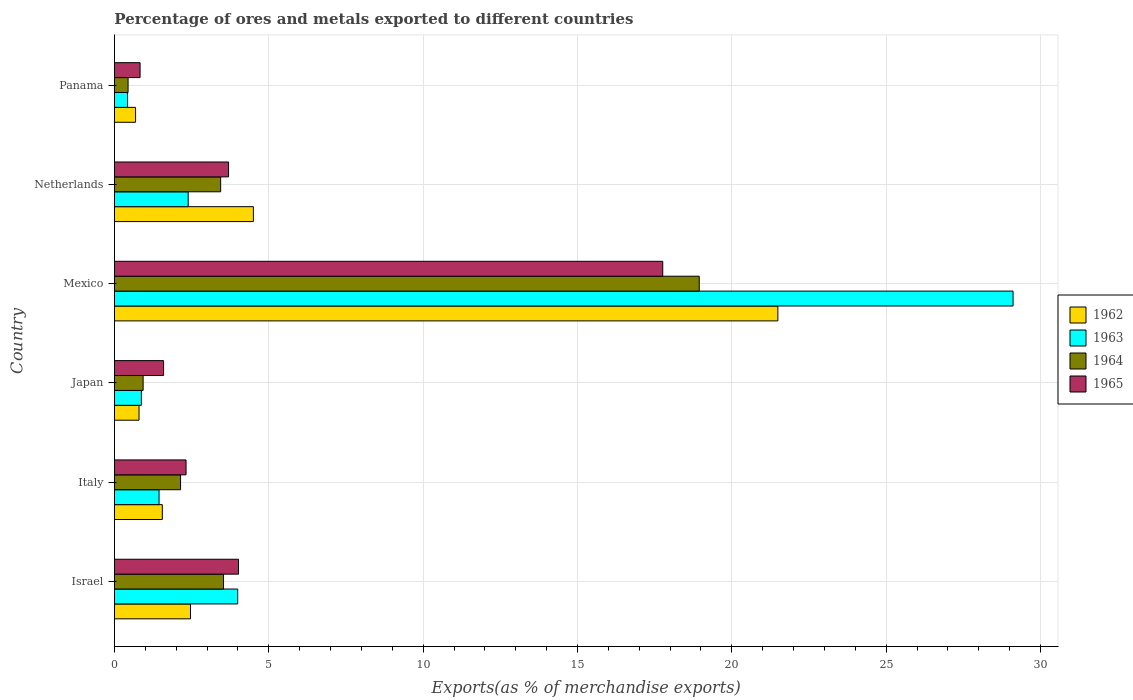How many different coloured bars are there?
Offer a terse response. 4. How many groups of bars are there?
Offer a terse response. 6. Are the number of bars per tick equal to the number of legend labels?
Make the answer very short. Yes. Are the number of bars on each tick of the Y-axis equal?
Your response must be concise. Yes. What is the percentage of exports to different countries in 1964 in Netherlands?
Make the answer very short. 3.44. Across all countries, what is the maximum percentage of exports to different countries in 1962?
Keep it short and to the point. 21.49. Across all countries, what is the minimum percentage of exports to different countries in 1963?
Your answer should be very brief. 0.43. In which country was the percentage of exports to different countries in 1964 minimum?
Ensure brevity in your answer.  Panama. What is the total percentage of exports to different countries in 1964 in the graph?
Keep it short and to the point. 29.43. What is the difference between the percentage of exports to different countries in 1963 in Mexico and that in Netherlands?
Your answer should be very brief. 26.72. What is the difference between the percentage of exports to different countries in 1962 in Mexico and the percentage of exports to different countries in 1964 in Netherlands?
Offer a very short reply. 18.05. What is the average percentage of exports to different countries in 1964 per country?
Your response must be concise. 4.91. What is the difference between the percentage of exports to different countries in 1965 and percentage of exports to different countries in 1964 in Panama?
Provide a succinct answer. 0.39. What is the ratio of the percentage of exports to different countries in 1963 in Israel to that in Italy?
Your answer should be compact. 2.76. Is the difference between the percentage of exports to different countries in 1965 in Italy and Netherlands greater than the difference between the percentage of exports to different countries in 1964 in Italy and Netherlands?
Your response must be concise. No. What is the difference between the highest and the second highest percentage of exports to different countries in 1963?
Make the answer very short. 25.12. What is the difference between the highest and the lowest percentage of exports to different countries in 1964?
Provide a succinct answer. 18.5. In how many countries, is the percentage of exports to different countries in 1962 greater than the average percentage of exports to different countries in 1962 taken over all countries?
Give a very brief answer. 1. What does the 3rd bar from the bottom in Israel represents?
Provide a succinct answer. 1964. Is it the case that in every country, the sum of the percentage of exports to different countries in 1965 and percentage of exports to different countries in 1962 is greater than the percentage of exports to different countries in 1964?
Keep it short and to the point. Yes. How many bars are there?
Your answer should be very brief. 24. Are the values on the major ticks of X-axis written in scientific E-notation?
Offer a terse response. No. Does the graph contain grids?
Your answer should be compact. Yes. Where does the legend appear in the graph?
Offer a very short reply. Center right. How many legend labels are there?
Ensure brevity in your answer.  4. How are the legend labels stacked?
Offer a terse response. Vertical. What is the title of the graph?
Your answer should be very brief. Percentage of ores and metals exported to different countries. Does "2012" appear as one of the legend labels in the graph?
Your answer should be very brief. No. What is the label or title of the X-axis?
Offer a terse response. Exports(as % of merchandise exports). What is the Exports(as % of merchandise exports) of 1962 in Israel?
Provide a short and direct response. 2.46. What is the Exports(as % of merchandise exports) in 1963 in Israel?
Your answer should be compact. 3.99. What is the Exports(as % of merchandise exports) of 1964 in Israel?
Ensure brevity in your answer.  3.53. What is the Exports(as % of merchandise exports) in 1965 in Israel?
Provide a succinct answer. 4.02. What is the Exports(as % of merchandise exports) in 1962 in Italy?
Ensure brevity in your answer.  1.55. What is the Exports(as % of merchandise exports) of 1963 in Italy?
Your answer should be compact. 1.45. What is the Exports(as % of merchandise exports) of 1964 in Italy?
Give a very brief answer. 2.14. What is the Exports(as % of merchandise exports) of 1965 in Italy?
Give a very brief answer. 2.32. What is the Exports(as % of merchandise exports) in 1962 in Japan?
Keep it short and to the point. 0.8. What is the Exports(as % of merchandise exports) of 1963 in Japan?
Provide a short and direct response. 0.87. What is the Exports(as % of merchandise exports) in 1964 in Japan?
Your answer should be very brief. 0.93. What is the Exports(as % of merchandise exports) of 1965 in Japan?
Provide a succinct answer. 1.59. What is the Exports(as % of merchandise exports) in 1962 in Mexico?
Ensure brevity in your answer.  21.49. What is the Exports(as % of merchandise exports) in 1963 in Mexico?
Make the answer very short. 29.11. What is the Exports(as % of merchandise exports) of 1964 in Mexico?
Your answer should be very brief. 18.94. What is the Exports(as % of merchandise exports) in 1965 in Mexico?
Keep it short and to the point. 17.76. What is the Exports(as % of merchandise exports) in 1962 in Netherlands?
Give a very brief answer. 4.5. What is the Exports(as % of merchandise exports) in 1963 in Netherlands?
Provide a short and direct response. 2.39. What is the Exports(as % of merchandise exports) of 1964 in Netherlands?
Your answer should be compact. 3.44. What is the Exports(as % of merchandise exports) in 1965 in Netherlands?
Offer a very short reply. 3.7. What is the Exports(as % of merchandise exports) in 1962 in Panama?
Give a very brief answer. 0.69. What is the Exports(as % of merchandise exports) in 1963 in Panama?
Offer a terse response. 0.43. What is the Exports(as % of merchandise exports) in 1964 in Panama?
Keep it short and to the point. 0.44. What is the Exports(as % of merchandise exports) of 1965 in Panama?
Your answer should be compact. 0.83. Across all countries, what is the maximum Exports(as % of merchandise exports) of 1962?
Ensure brevity in your answer.  21.49. Across all countries, what is the maximum Exports(as % of merchandise exports) in 1963?
Ensure brevity in your answer.  29.11. Across all countries, what is the maximum Exports(as % of merchandise exports) in 1964?
Provide a succinct answer. 18.94. Across all countries, what is the maximum Exports(as % of merchandise exports) of 1965?
Provide a succinct answer. 17.76. Across all countries, what is the minimum Exports(as % of merchandise exports) of 1962?
Ensure brevity in your answer.  0.69. Across all countries, what is the minimum Exports(as % of merchandise exports) of 1963?
Make the answer very short. 0.43. Across all countries, what is the minimum Exports(as % of merchandise exports) of 1964?
Provide a short and direct response. 0.44. Across all countries, what is the minimum Exports(as % of merchandise exports) in 1965?
Provide a succinct answer. 0.83. What is the total Exports(as % of merchandise exports) of 1962 in the graph?
Provide a succinct answer. 31.49. What is the total Exports(as % of merchandise exports) in 1963 in the graph?
Provide a succinct answer. 38.24. What is the total Exports(as % of merchandise exports) in 1964 in the graph?
Your response must be concise. 29.43. What is the total Exports(as % of merchandise exports) of 1965 in the graph?
Provide a succinct answer. 30.22. What is the difference between the Exports(as % of merchandise exports) in 1963 in Israel and that in Italy?
Your answer should be compact. 2.55. What is the difference between the Exports(as % of merchandise exports) in 1964 in Israel and that in Italy?
Offer a very short reply. 1.39. What is the difference between the Exports(as % of merchandise exports) in 1965 in Israel and that in Italy?
Provide a short and direct response. 1.7. What is the difference between the Exports(as % of merchandise exports) in 1962 in Israel and that in Japan?
Offer a terse response. 1.67. What is the difference between the Exports(as % of merchandise exports) of 1963 in Israel and that in Japan?
Ensure brevity in your answer.  3.12. What is the difference between the Exports(as % of merchandise exports) of 1964 in Israel and that in Japan?
Offer a terse response. 2.6. What is the difference between the Exports(as % of merchandise exports) in 1965 in Israel and that in Japan?
Your response must be concise. 2.43. What is the difference between the Exports(as % of merchandise exports) in 1962 in Israel and that in Mexico?
Provide a succinct answer. -19.03. What is the difference between the Exports(as % of merchandise exports) of 1963 in Israel and that in Mexico?
Make the answer very short. -25.12. What is the difference between the Exports(as % of merchandise exports) in 1964 in Israel and that in Mexico?
Your answer should be very brief. -15.41. What is the difference between the Exports(as % of merchandise exports) of 1965 in Israel and that in Mexico?
Provide a short and direct response. -13.74. What is the difference between the Exports(as % of merchandise exports) in 1962 in Israel and that in Netherlands?
Ensure brevity in your answer.  -2.04. What is the difference between the Exports(as % of merchandise exports) in 1963 in Israel and that in Netherlands?
Keep it short and to the point. 1.6. What is the difference between the Exports(as % of merchandise exports) of 1964 in Israel and that in Netherlands?
Your answer should be very brief. 0.09. What is the difference between the Exports(as % of merchandise exports) of 1965 in Israel and that in Netherlands?
Provide a short and direct response. 0.32. What is the difference between the Exports(as % of merchandise exports) in 1962 in Israel and that in Panama?
Provide a succinct answer. 1.78. What is the difference between the Exports(as % of merchandise exports) in 1963 in Israel and that in Panama?
Make the answer very short. 3.57. What is the difference between the Exports(as % of merchandise exports) of 1964 in Israel and that in Panama?
Offer a very short reply. 3.09. What is the difference between the Exports(as % of merchandise exports) of 1965 in Israel and that in Panama?
Provide a short and direct response. 3.19. What is the difference between the Exports(as % of merchandise exports) in 1962 in Italy and that in Japan?
Your response must be concise. 0.75. What is the difference between the Exports(as % of merchandise exports) of 1963 in Italy and that in Japan?
Your response must be concise. 0.57. What is the difference between the Exports(as % of merchandise exports) of 1964 in Italy and that in Japan?
Your answer should be compact. 1.21. What is the difference between the Exports(as % of merchandise exports) of 1965 in Italy and that in Japan?
Provide a short and direct response. 0.73. What is the difference between the Exports(as % of merchandise exports) of 1962 in Italy and that in Mexico?
Offer a very short reply. -19.94. What is the difference between the Exports(as % of merchandise exports) in 1963 in Italy and that in Mexico?
Ensure brevity in your answer.  -27.66. What is the difference between the Exports(as % of merchandise exports) in 1964 in Italy and that in Mexico?
Provide a short and direct response. -16.8. What is the difference between the Exports(as % of merchandise exports) in 1965 in Italy and that in Mexico?
Make the answer very short. -15.44. What is the difference between the Exports(as % of merchandise exports) in 1962 in Italy and that in Netherlands?
Ensure brevity in your answer.  -2.95. What is the difference between the Exports(as % of merchandise exports) of 1963 in Italy and that in Netherlands?
Ensure brevity in your answer.  -0.94. What is the difference between the Exports(as % of merchandise exports) in 1964 in Italy and that in Netherlands?
Ensure brevity in your answer.  -1.3. What is the difference between the Exports(as % of merchandise exports) in 1965 in Italy and that in Netherlands?
Provide a succinct answer. -1.38. What is the difference between the Exports(as % of merchandise exports) of 1962 in Italy and that in Panama?
Give a very brief answer. 0.87. What is the difference between the Exports(as % of merchandise exports) of 1963 in Italy and that in Panama?
Your answer should be very brief. 1.02. What is the difference between the Exports(as % of merchandise exports) of 1964 in Italy and that in Panama?
Your answer should be very brief. 1.7. What is the difference between the Exports(as % of merchandise exports) of 1965 in Italy and that in Panama?
Offer a very short reply. 1.49. What is the difference between the Exports(as % of merchandise exports) in 1962 in Japan and that in Mexico?
Give a very brief answer. -20.69. What is the difference between the Exports(as % of merchandise exports) of 1963 in Japan and that in Mexico?
Your response must be concise. -28.24. What is the difference between the Exports(as % of merchandise exports) in 1964 in Japan and that in Mexico?
Ensure brevity in your answer.  -18.01. What is the difference between the Exports(as % of merchandise exports) of 1965 in Japan and that in Mexico?
Provide a short and direct response. -16.17. What is the difference between the Exports(as % of merchandise exports) in 1962 in Japan and that in Netherlands?
Offer a terse response. -3.7. What is the difference between the Exports(as % of merchandise exports) of 1963 in Japan and that in Netherlands?
Keep it short and to the point. -1.52. What is the difference between the Exports(as % of merchandise exports) of 1964 in Japan and that in Netherlands?
Your answer should be very brief. -2.51. What is the difference between the Exports(as % of merchandise exports) in 1965 in Japan and that in Netherlands?
Your answer should be compact. -2.11. What is the difference between the Exports(as % of merchandise exports) of 1962 in Japan and that in Panama?
Keep it short and to the point. 0.11. What is the difference between the Exports(as % of merchandise exports) of 1963 in Japan and that in Panama?
Your response must be concise. 0.45. What is the difference between the Exports(as % of merchandise exports) of 1964 in Japan and that in Panama?
Your answer should be compact. 0.49. What is the difference between the Exports(as % of merchandise exports) in 1965 in Japan and that in Panama?
Make the answer very short. 0.76. What is the difference between the Exports(as % of merchandise exports) of 1962 in Mexico and that in Netherlands?
Provide a succinct answer. 16.99. What is the difference between the Exports(as % of merchandise exports) of 1963 in Mexico and that in Netherlands?
Your answer should be compact. 26.72. What is the difference between the Exports(as % of merchandise exports) in 1964 in Mexico and that in Netherlands?
Provide a succinct answer. 15.5. What is the difference between the Exports(as % of merchandise exports) of 1965 in Mexico and that in Netherlands?
Offer a very short reply. 14.06. What is the difference between the Exports(as % of merchandise exports) of 1962 in Mexico and that in Panama?
Make the answer very short. 20.81. What is the difference between the Exports(as % of merchandise exports) in 1963 in Mexico and that in Panama?
Your response must be concise. 28.68. What is the difference between the Exports(as % of merchandise exports) in 1964 in Mexico and that in Panama?
Give a very brief answer. 18.5. What is the difference between the Exports(as % of merchandise exports) in 1965 in Mexico and that in Panama?
Make the answer very short. 16.93. What is the difference between the Exports(as % of merchandise exports) in 1962 in Netherlands and that in Panama?
Keep it short and to the point. 3.82. What is the difference between the Exports(as % of merchandise exports) of 1963 in Netherlands and that in Panama?
Keep it short and to the point. 1.96. What is the difference between the Exports(as % of merchandise exports) of 1964 in Netherlands and that in Panama?
Your answer should be compact. 3. What is the difference between the Exports(as % of merchandise exports) in 1965 in Netherlands and that in Panama?
Provide a short and direct response. 2.87. What is the difference between the Exports(as % of merchandise exports) of 1962 in Israel and the Exports(as % of merchandise exports) of 1963 in Italy?
Your response must be concise. 1.02. What is the difference between the Exports(as % of merchandise exports) of 1962 in Israel and the Exports(as % of merchandise exports) of 1964 in Italy?
Keep it short and to the point. 0.32. What is the difference between the Exports(as % of merchandise exports) of 1962 in Israel and the Exports(as % of merchandise exports) of 1965 in Italy?
Your response must be concise. 0.14. What is the difference between the Exports(as % of merchandise exports) of 1963 in Israel and the Exports(as % of merchandise exports) of 1964 in Italy?
Give a very brief answer. 1.85. What is the difference between the Exports(as % of merchandise exports) in 1963 in Israel and the Exports(as % of merchandise exports) in 1965 in Italy?
Make the answer very short. 1.67. What is the difference between the Exports(as % of merchandise exports) of 1964 in Israel and the Exports(as % of merchandise exports) of 1965 in Italy?
Your answer should be compact. 1.21. What is the difference between the Exports(as % of merchandise exports) in 1962 in Israel and the Exports(as % of merchandise exports) in 1963 in Japan?
Your answer should be compact. 1.59. What is the difference between the Exports(as % of merchandise exports) in 1962 in Israel and the Exports(as % of merchandise exports) in 1964 in Japan?
Your response must be concise. 1.53. What is the difference between the Exports(as % of merchandise exports) in 1962 in Israel and the Exports(as % of merchandise exports) in 1965 in Japan?
Offer a terse response. 0.87. What is the difference between the Exports(as % of merchandise exports) of 1963 in Israel and the Exports(as % of merchandise exports) of 1964 in Japan?
Ensure brevity in your answer.  3.06. What is the difference between the Exports(as % of merchandise exports) of 1963 in Israel and the Exports(as % of merchandise exports) of 1965 in Japan?
Make the answer very short. 2.4. What is the difference between the Exports(as % of merchandise exports) of 1964 in Israel and the Exports(as % of merchandise exports) of 1965 in Japan?
Ensure brevity in your answer.  1.94. What is the difference between the Exports(as % of merchandise exports) of 1962 in Israel and the Exports(as % of merchandise exports) of 1963 in Mexico?
Ensure brevity in your answer.  -26.64. What is the difference between the Exports(as % of merchandise exports) of 1962 in Israel and the Exports(as % of merchandise exports) of 1964 in Mexico?
Keep it short and to the point. -16.48. What is the difference between the Exports(as % of merchandise exports) of 1962 in Israel and the Exports(as % of merchandise exports) of 1965 in Mexico?
Offer a very short reply. -15.3. What is the difference between the Exports(as % of merchandise exports) of 1963 in Israel and the Exports(as % of merchandise exports) of 1964 in Mexico?
Make the answer very short. -14.95. What is the difference between the Exports(as % of merchandise exports) of 1963 in Israel and the Exports(as % of merchandise exports) of 1965 in Mexico?
Give a very brief answer. -13.77. What is the difference between the Exports(as % of merchandise exports) of 1964 in Israel and the Exports(as % of merchandise exports) of 1965 in Mexico?
Make the answer very short. -14.23. What is the difference between the Exports(as % of merchandise exports) of 1962 in Israel and the Exports(as % of merchandise exports) of 1963 in Netherlands?
Give a very brief answer. 0.07. What is the difference between the Exports(as % of merchandise exports) of 1962 in Israel and the Exports(as % of merchandise exports) of 1964 in Netherlands?
Offer a terse response. -0.98. What is the difference between the Exports(as % of merchandise exports) in 1962 in Israel and the Exports(as % of merchandise exports) in 1965 in Netherlands?
Your answer should be compact. -1.23. What is the difference between the Exports(as % of merchandise exports) of 1963 in Israel and the Exports(as % of merchandise exports) of 1964 in Netherlands?
Provide a succinct answer. 0.55. What is the difference between the Exports(as % of merchandise exports) of 1963 in Israel and the Exports(as % of merchandise exports) of 1965 in Netherlands?
Offer a terse response. 0.3. What is the difference between the Exports(as % of merchandise exports) of 1964 in Israel and the Exports(as % of merchandise exports) of 1965 in Netherlands?
Provide a short and direct response. -0.16. What is the difference between the Exports(as % of merchandise exports) in 1962 in Israel and the Exports(as % of merchandise exports) in 1963 in Panama?
Make the answer very short. 2.04. What is the difference between the Exports(as % of merchandise exports) of 1962 in Israel and the Exports(as % of merchandise exports) of 1964 in Panama?
Your answer should be very brief. 2.02. What is the difference between the Exports(as % of merchandise exports) of 1962 in Israel and the Exports(as % of merchandise exports) of 1965 in Panama?
Offer a terse response. 1.63. What is the difference between the Exports(as % of merchandise exports) of 1963 in Israel and the Exports(as % of merchandise exports) of 1964 in Panama?
Provide a short and direct response. 3.55. What is the difference between the Exports(as % of merchandise exports) of 1963 in Israel and the Exports(as % of merchandise exports) of 1965 in Panama?
Your answer should be very brief. 3.16. What is the difference between the Exports(as % of merchandise exports) of 1964 in Israel and the Exports(as % of merchandise exports) of 1965 in Panama?
Your response must be concise. 2.7. What is the difference between the Exports(as % of merchandise exports) in 1962 in Italy and the Exports(as % of merchandise exports) in 1963 in Japan?
Make the answer very short. 0.68. What is the difference between the Exports(as % of merchandise exports) in 1962 in Italy and the Exports(as % of merchandise exports) in 1964 in Japan?
Keep it short and to the point. 0.62. What is the difference between the Exports(as % of merchandise exports) of 1962 in Italy and the Exports(as % of merchandise exports) of 1965 in Japan?
Keep it short and to the point. -0.04. What is the difference between the Exports(as % of merchandise exports) of 1963 in Italy and the Exports(as % of merchandise exports) of 1964 in Japan?
Your response must be concise. 0.52. What is the difference between the Exports(as % of merchandise exports) in 1963 in Italy and the Exports(as % of merchandise exports) in 1965 in Japan?
Make the answer very short. -0.15. What is the difference between the Exports(as % of merchandise exports) of 1964 in Italy and the Exports(as % of merchandise exports) of 1965 in Japan?
Provide a short and direct response. 0.55. What is the difference between the Exports(as % of merchandise exports) in 1962 in Italy and the Exports(as % of merchandise exports) in 1963 in Mexico?
Provide a short and direct response. -27.56. What is the difference between the Exports(as % of merchandise exports) of 1962 in Italy and the Exports(as % of merchandise exports) of 1964 in Mexico?
Provide a succinct answer. -17.39. What is the difference between the Exports(as % of merchandise exports) in 1962 in Italy and the Exports(as % of merchandise exports) in 1965 in Mexico?
Ensure brevity in your answer.  -16.21. What is the difference between the Exports(as % of merchandise exports) of 1963 in Italy and the Exports(as % of merchandise exports) of 1964 in Mexico?
Keep it short and to the point. -17.5. What is the difference between the Exports(as % of merchandise exports) of 1963 in Italy and the Exports(as % of merchandise exports) of 1965 in Mexico?
Offer a terse response. -16.32. What is the difference between the Exports(as % of merchandise exports) in 1964 in Italy and the Exports(as % of merchandise exports) in 1965 in Mexico?
Ensure brevity in your answer.  -15.62. What is the difference between the Exports(as % of merchandise exports) in 1962 in Italy and the Exports(as % of merchandise exports) in 1963 in Netherlands?
Provide a short and direct response. -0.84. What is the difference between the Exports(as % of merchandise exports) in 1962 in Italy and the Exports(as % of merchandise exports) in 1964 in Netherlands?
Offer a very short reply. -1.89. What is the difference between the Exports(as % of merchandise exports) of 1962 in Italy and the Exports(as % of merchandise exports) of 1965 in Netherlands?
Provide a succinct answer. -2.15. What is the difference between the Exports(as % of merchandise exports) in 1963 in Italy and the Exports(as % of merchandise exports) in 1964 in Netherlands?
Offer a terse response. -2. What is the difference between the Exports(as % of merchandise exports) in 1963 in Italy and the Exports(as % of merchandise exports) in 1965 in Netherlands?
Your answer should be very brief. -2.25. What is the difference between the Exports(as % of merchandise exports) in 1964 in Italy and the Exports(as % of merchandise exports) in 1965 in Netherlands?
Provide a short and direct response. -1.56. What is the difference between the Exports(as % of merchandise exports) in 1962 in Italy and the Exports(as % of merchandise exports) in 1963 in Panama?
Make the answer very short. 1.12. What is the difference between the Exports(as % of merchandise exports) in 1962 in Italy and the Exports(as % of merchandise exports) in 1964 in Panama?
Ensure brevity in your answer.  1.11. What is the difference between the Exports(as % of merchandise exports) of 1962 in Italy and the Exports(as % of merchandise exports) of 1965 in Panama?
Make the answer very short. 0.72. What is the difference between the Exports(as % of merchandise exports) in 1963 in Italy and the Exports(as % of merchandise exports) in 1965 in Panama?
Make the answer very short. 0.61. What is the difference between the Exports(as % of merchandise exports) in 1964 in Italy and the Exports(as % of merchandise exports) in 1965 in Panama?
Give a very brief answer. 1.31. What is the difference between the Exports(as % of merchandise exports) of 1962 in Japan and the Exports(as % of merchandise exports) of 1963 in Mexico?
Provide a succinct answer. -28.31. What is the difference between the Exports(as % of merchandise exports) in 1962 in Japan and the Exports(as % of merchandise exports) in 1964 in Mexico?
Your answer should be very brief. -18.15. What is the difference between the Exports(as % of merchandise exports) of 1962 in Japan and the Exports(as % of merchandise exports) of 1965 in Mexico?
Keep it short and to the point. -16.97. What is the difference between the Exports(as % of merchandise exports) in 1963 in Japan and the Exports(as % of merchandise exports) in 1964 in Mexico?
Ensure brevity in your answer.  -18.07. What is the difference between the Exports(as % of merchandise exports) of 1963 in Japan and the Exports(as % of merchandise exports) of 1965 in Mexico?
Provide a succinct answer. -16.89. What is the difference between the Exports(as % of merchandise exports) in 1964 in Japan and the Exports(as % of merchandise exports) in 1965 in Mexico?
Your answer should be compact. -16.83. What is the difference between the Exports(as % of merchandise exports) of 1962 in Japan and the Exports(as % of merchandise exports) of 1963 in Netherlands?
Your response must be concise. -1.59. What is the difference between the Exports(as % of merchandise exports) in 1962 in Japan and the Exports(as % of merchandise exports) in 1964 in Netherlands?
Keep it short and to the point. -2.64. What is the difference between the Exports(as % of merchandise exports) of 1962 in Japan and the Exports(as % of merchandise exports) of 1965 in Netherlands?
Offer a very short reply. -2.9. What is the difference between the Exports(as % of merchandise exports) in 1963 in Japan and the Exports(as % of merchandise exports) in 1964 in Netherlands?
Give a very brief answer. -2.57. What is the difference between the Exports(as % of merchandise exports) in 1963 in Japan and the Exports(as % of merchandise exports) in 1965 in Netherlands?
Give a very brief answer. -2.82. What is the difference between the Exports(as % of merchandise exports) in 1964 in Japan and the Exports(as % of merchandise exports) in 1965 in Netherlands?
Keep it short and to the point. -2.77. What is the difference between the Exports(as % of merchandise exports) of 1962 in Japan and the Exports(as % of merchandise exports) of 1963 in Panama?
Keep it short and to the point. 0.37. What is the difference between the Exports(as % of merchandise exports) in 1962 in Japan and the Exports(as % of merchandise exports) in 1964 in Panama?
Offer a terse response. 0.35. What is the difference between the Exports(as % of merchandise exports) in 1962 in Japan and the Exports(as % of merchandise exports) in 1965 in Panama?
Offer a terse response. -0.03. What is the difference between the Exports(as % of merchandise exports) in 1963 in Japan and the Exports(as % of merchandise exports) in 1964 in Panama?
Make the answer very short. 0.43. What is the difference between the Exports(as % of merchandise exports) in 1963 in Japan and the Exports(as % of merchandise exports) in 1965 in Panama?
Provide a succinct answer. 0.04. What is the difference between the Exports(as % of merchandise exports) of 1964 in Japan and the Exports(as % of merchandise exports) of 1965 in Panama?
Offer a very short reply. 0.1. What is the difference between the Exports(as % of merchandise exports) in 1962 in Mexico and the Exports(as % of merchandise exports) in 1963 in Netherlands?
Ensure brevity in your answer.  19.1. What is the difference between the Exports(as % of merchandise exports) in 1962 in Mexico and the Exports(as % of merchandise exports) in 1964 in Netherlands?
Offer a very short reply. 18.05. What is the difference between the Exports(as % of merchandise exports) in 1962 in Mexico and the Exports(as % of merchandise exports) in 1965 in Netherlands?
Offer a terse response. 17.79. What is the difference between the Exports(as % of merchandise exports) in 1963 in Mexico and the Exports(as % of merchandise exports) in 1964 in Netherlands?
Give a very brief answer. 25.67. What is the difference between the Exports(as % of merchandise exports) in 1963 in Mexico and the Exports(as % of merchandise exports) in 1965 in Netherlands?
Provide a succinct answer. 25.41. What is the difference between the Exports(as % of merchandise exports) in 1964 in Mexico and the Exports(as % of merchandise exports) in 1965 in Netherlands?
Your answer should be compact. 15.25. What is the difference between the Exports(as % of merchandise exports) of 1962 in Mexico and the Exports(as % of merchandise exports) of 1963 in Panama?
Provide a succinct answer. 21.06. What is the difference between the Exports(as % of merchandise exports) of 1962 in Mexico and the Exports(as % of merchandise exports) of 1964 in Panama?
Your answer should be compact. 21.05. What is the difference between the Exports(as % of merchandise exports) of 1962 in Mexico and the Exports(as % of merchandise exports) of 1965 in Panama?
Your answer should be compact. 20.66. What is the difference between the Exports(as % of merchandise exports) in 1963 in Mexico and the Exports(as % of merchandise exports) in 1964 in Panama?
Offer a very short reply. 28.67. What is the difference between the Exports(as % of merchandise exports) of 1963 in Mexico and the Exports(as % of merchandise exports) of 1965 in Panama?
Offer a terse response. 28.28. What is the difference between the Exports(as % of merchandise exports) of 1964 in Mexico and the Exports(as % of merchandise exports) of 1965 in Panama?
Offer a terse response. 18.11. What is the difference between the Exports(as % of merchandise exports) of 1962 in Netherlands and the Exports(as % of merchandise exports) of 1963 in Panama?
Make the answer very short. 4.07. What is the difference between the Exports(as % of merchandise exports) of 1962 in Netherlands and the Exports(as % of merchandise exports) of 1964 in Panama?
Provide a succinct answer. 4.06. What is the difference between the Exports(as % of merchandise exports) in 1962 in Netherlands and the Exports(as % of merchandise exports) in 1965 in Panama?
Keep it short and to the point. 3.67. What is the difference between the Exports(as % of merchandise exports) in 1963 in Netherlands and the Exports(as % of merchandise exports) in 1964 in Panama?
Give a very brief answer. 1.95. What is the difference between the Exports(as % of merchandise exports) in 1963 in Netherlands and the Exports(as % of merchandise exports) in 1965 in Panama?
Keep it short and to the point. 1.56. What is the difference between the Exports(as % of merchandise exports) of 1964 in Netherlands and the Exports(as % of merchandise exports) of 1965 in Panama?
Provide a succinct answer. 2.61. What is the average Exports(as % of merchandise exports) in 1962 per country?
Your answer should be very brief. 5.25. What is the average Exports(as % of merchandise exports) of 1963 per country?
Give a very brief answer. 6.37. What is the average Exports(as % of merchandise exports) of 1964 per country?
Offer a terse response. 4.91. What is the average Exports(as % of merchandise exports) in 1965 per country?
Your response must be concise. 5.04. What is the difference between the Exports(as % of merchandise exports) in 1962 and Exports(as % of merchandise exports) in 1963 in Israel?
Give a very brief answer. -1.53. What is the difference between the Exports(as % of merchandise exports) of 1962 and Exports(as % of merchandise exports) of 1964 in Israel?
Provide a succinct answer. -1.07. What is the difference between the Exports(as % of merchandise exports) of 1962 and Exports(as % of merchandise exports) of 1965 in Israel?
Ensure brevity in your answer.  -1.56. What is the difference between the Exports(as % of merchandise exports) of 1963 and Exports(as % of merchandise exports) of 1964 in Israel?
Your answer should be compact. 0.46. What is the difference between the Exports(as % of merchandise exports) in 1963 and Exports(as % of merchandise exports) in 1965 in Israel?
Provide a short and direct response. -0.03. What is the difference between the Exports(as % of merchandise exports) in 1964 and Exports(as % of merchandise exports) in 1965 in Israel?
Provide a succinct answer. -0.49. What is the difference between the Exports(as % of merchandise exports) of 1962 and Exports(as % of merchandise exports) of 1963 in Italy?
Provide a succinct answer. 0.11. What is the difference between the Exports(as % of merchandise exports) in 1962 and Exports(as % of merchandise exports) in 1964 in Italy?
Offer a very short reply. -0.59. What is the difference between the Exports(as % of merchandise exports) in 1962 and Exports(as % of merchandise exports) in 1965 in Italy?
Make the answer very short. -0.77. What is the difference between the Exports(as % of merchandise exports) in 1963 and Exports(as % of merchandise exports) in 1964 in Italy?
Keep it short and to the point. -0.7. What is the difference between the Exports(as % of merchandise exports) in 1963 and Exports(as % of merchandise exports) in 1965 in Italy?
Provide a succinct answer. -0.87. What is the difference between the Exports(as % of merchandise exports) in 1964 and Exports(as % of merchandise exports) in 1965 in Italy?
Offer a very short reply. -0.18. What is the difference between the Exports(as % of merchandise exports) in 1962 and Exports(as % of merchandise exports) in 1963 in Japan?
Provide a short and direct response. -0.08. What is the difference between the Exports(as % of merchandise exports) of 1962 and Exports(as % of merchandise exports) of 1964 in Japan?
Provide a succinct answer. -0.13. What is the difference between the Exports(as % of merchandise exports) in 1962 and Exports(as % of merchandise exports) in 1965 in Japan?
Make the answer very short. -0.8. What is the difference between the Exports(as % of merchandise exports) of 1963 and Exports(as % of merchandise exports) of 1964 in Japan?
Your answer should be very brief. -0.06. What is the difference between the Exports(as % of merchandise exports) in 1963 and Exports(as % of merchandise exports) in 1965 in Japan?
Your answer should be very brief. -0.72. What is the difference between the Exports(as % of merchandise exports) of 1964 and Exports(as % of merchandise exports) of 1965 in Japan?
Keep it short and to the point. -0.66. What is the difference between the Exports(as % of merchandise exports) of 1962 and Exports(as % of merchandise exports) of 1963 in Mexico?
Make the answer very short. -7.62. What is the difference between the Exports(as % of merchandise exports) of 1962 and Exports(as % of merchandise exports) of 1964 in Mexico?
Your answer should be compact. 2.55. What is the difference between the Exports(as % of merchandise exports) of 1962 and Exports(as % of merchandise exports) of 1965 in Mexico?
Your response must be concise. 3.73. What is the difference between the Exports(as % of merchandise exports) in 1963 and Exports(as % of merchandise exports) in 1964 in Mexico?
Keep it short and to the point. 10.16. What is the difference between the Exports(as % of merchandise exports) in 1963 and Exports(as % of merchandise exports) in 1965 in Mexico?
Keep it short and to the point. 11.35. What is the difference between the Exports(as % of merchandise exports) in 1964 and Exports(as % of merchandise exports) in 1965 in Mexico?
Provide a succinct answer. 1.18. What is the difference between the Exports(as % of merchandise exports) of 1962 and Exports(as % of merchandise exports) of 1963 in Netherlands?
Your response must be concise. 2.11. What is the difference between the Exports(as % of merchandise exports) of 1962 and Exports(as % of merchandise exports) of 1964 in Netherlands?
Offer a very short reply. 1.06. What is the difference between the Exports(as % of merchandise exports) in 1962 and Exports(as % of merchandise exports) in 1965 in Netherlands?
Keep it short and to the point. 0.8. What is the difference between the Exports(as % of merchandise exports) of 1963 and Exports(as % of merchandise exports) of 1964 in Netherlands?
Keep it short and to the point. -1.05. What is the difference between the Exports(as % of merchandise exports) of 1963 and Exports(as % of merchandise exports) of 1965 in Netherlands?
Your response must be concise. -1.31. What is the difference between the Exports(as % of merchandise exports) of 1964 and Exports(as % of merchandise exports) of 1965 in Netherlands?
Provide a succinct answer. -0.26. What is the difference between the Exports(as % of merchandise exports) of 1962 and Exports(as % of merchandise exports) of 1963 in Panama?
Make the answer very short. 0.26. What is the difference between the Exports(as % of merchandise exports) of 1962 and Exports(as % of merchandise exports) of 1964 in Panama?
Provide a succinct answer. 0.24. What is the difference between the Exports(as % of merchandise exports) in 1962 and Exports(as % of merchandise exports) in 1965 in Panama?
Provide a short and direct response. -0.15. What is the difference between the Exports(as % of merchandise exports) in 1963 and Exports(as % of merchandise exports) in 1964 in Panama?
Keep it short and to the point. -0.02. What is the difference between the Exports(as % of merchandise exports) in 1963 and Exports(as % of merchandise exports) in 1965 in Panama?
Provide a succinct answer. -0.4. What is the difference between the Exports(as % of merchandise exports) of 1964 and Exports(as % of merchandise exports) of 1965 in Panama?
Provide a short and direct response. -0.39. What is the ratio of the Exports(as % of merchandise exports) in 1962 in Israel to that in Italy?
Your response must be concise. 1.59. What is the ratio of the Exports(as % of merchandise exports) in 1963 in Israel to that in Italy?
Give a very brief answer. 2.76. What is the ratio of the Exports(as % of merchandise exports) of 1964 in Israel to that in Italy?
Your response must be concise. 1.65. What is the ratio of the Exports(as % of merchandise exports) in 1965 in Israel to that in Italy?
Your answer should be compact. 1.73. What is the ratio of the Exports(as % of merchandise exports) of 1962 in Israel to that in Japan?
Ensure brevity in your answer.  3.09. What is the ratio of the Exports(as % of merchandise exports) in 1963 in Israel to that in Japan?
Ensure brevity in your answer.  4.57. What is the ratio of the Exports(as % of merchandise exports) of 1964 in Israel to that in Japan?
Offer a terse response. 3.8. What is the ratio of the Exports(as % of merchandise exports) in 1965 in Israel to that in Japan?
Provide a succinct answer. 2.52. What is the ratio of the Exports(as % of merchandise exports) of 1962 in Israel to that in Mexico?
Ensure brevity in your answer.  0.11. What is the ratio of the Exports(as % of merchandise exports) in 1963 in Israel to that in Mexico?
Provide a succinct answer. 0.14. What is the ratio of the Exports(as % of merchandise exports) of 1964 in Israel to that in Mexico?
Ensure brevity in your answer.  0.19. What is the ratio of the Exports(as % of merchandise exports) in 1965 in Israel to that in Mexico?
Keep it short and to the point. 0.23. What is the ratio of the Exports(as % of merchandise exports) in 1962 in Israel to that in Netherlands?
Provide a succinct answer. 0.55. What is the ratio of the Exports(as % of merchandise exports) of 1963 in Israel to that in Netherlands?
Your response must be concise. 1.67. What is the ratio of the Exports(as % of merchandise exports) of 1965 in Israel to that in Netherlands?
Your answer should be very brief. 1.09. What is the ratio of the Exports(as % of merchandise exports) of 1962 in Israel to that in Panama?
Provide a succinct answer. 3.6. What is the ratio of the Exports(as % of merchandise exports) in 1963 in Israel to that in Panama?
Make the answer very short. 9.37. What is the ratio of the Exports(as % of merchandise exports) of 1964 in Israel to that in Panama?
Offer a very short reply. 7.99. What is the ratio of the Exports(as % of merchandise exports) in 1965 in Israel to that in Panama?
Provide a short and direct response. 4.84. What is the ratio of the Exports(as % of merchandise exports) of 1962 in Italy to that in Japan?
Make the answer very short. 1.95. What is the ratio of the Exports(as % of merchandise exports) in 1963 in Italy to that in Japan?
Your answer should be very brief. 1.66. What is the ratio of the Exports(as % of merchandise exports) of 1964 in Italy to that in Japan?
Ensure brevity in your answer.  2.31. What is the ratio of the Exports(as % of merchandise exports) of 1965 in Italy to that in Japan?
Ensure brevity in your answer.  1.46. What is the ratio of the Exports(as % of merchandise exports) in 1962 in Italy to that in Mexico?
Keep it short and to the point. 0.07. What is the ratio of the Exports(as % of merchandise exports) of 1963 in Italy to that in Mexico?
Offer a very short reply. 0.05. What is the ratio of the Exports(as % of merchandise exports) in 1964 in Italy to that in Mexico?
Your response must be concise. 0.11. What is the ratio of the Exports(as % of merchandise exports) in 1965 in Italy to that in Mexico?
Ensure brevity in your answer.  0.13. What is the ratio of the Exports(as % of merchandise exports) of 1962 in Italy to that in Netherlands?
Offer a terse response. 0.34. What is the ratio of the Exports(as % of merchandise exports) of 1963 in Italy to that in Netherlands?
Provide a short and direct response. 0.6. What is the ratio of the Exports(as % of merchandise exports) of 1964 in Italy to that in Netherlands?
Offer a very short reply. 0.62. What is the ratio of the Exports(as % of merchandise exports) in 1965 in Italy to that in Netherlands?
Offer a terse response. 0.63. What is the ratio of the Exports(as % of merchandise exports) of 1962 in Italy to that in Panama?
Make the answer very short. 2.26. What is the ratio of the Exports(as % of merchandise exports) of 1963 in Italy to that in Panama?
Your answer should be very brief. 3.39. What is the ratio of the Exports(as % of merchandise exports) of 1964 in Italy to that in Panama?
Offer a terse response. 4.84. What is the ratio of the Exports(as % of merchandise exports) in 1965 in Italy to that in Panama?
Offer a terse response. 2.79. What is the ratio of the Exports(as % of merchandise exports) in 1962 in Japan to that in Mexico?
Offer a terse response. 0.04. What is the ratio of the Exports(as % of merchandise exports) in 1964 in Japan to that in Mexico?
Make the answer very short. 0.05. What is the ratio of the Exports(as % of merchandise exports) in 1965 in Japan to that in Mexico?
Offer a very short reply. 0.09. What is the ratio of the Exports(as % of merchandise exports) of 1962 in Japan to that in Netherlands?
Your response must be concise. 0.18. What is the ratio of the Exports(as % of merchandise exports) of 1963 in Japan to that in Netherlands?
Offer a terse response. 0.37. What is the ratio of the Exports(as % of merchandise exports) in 1964 in Japan to that in Netherlands?
Provide a succinct answer. 0.27. What is the ratio of the Exports(as % of merchandise exports) of 1965 in Japan to that in Netherlands?
Give a very brief answer. 0.43. What is the ratio of the Exports(as % of merchandise exports) of 1962 in Japan to that in Panama?
Make the answer very short. 1.16. What is the ratio of the Exports(as % of merchandise exports) of 1963 in Japan to that in Panama?
Make the answer very short. 2.05. What is the ratio of the Exports(as % of merchandise exports) in 1964 in Japan to that in Panama?
Keep it short and to the point. 2.1. What is the ratio of the Exports(as % of merchandise exports) in 1965 in Japan to that in Panama?
Give a very brief answer. 1.92. What is the ratio of the Exports(as % of merchandise exports) in 1962 in Mexico to that in Netherlands?
Make the answer very short. 4.77. What is the ratio of the Exports(as % of merchandise exports) of 1963 in Mexico to that in Netherlands?
Your answer should be very brief. 12.18. What is the ratio of the Exports(as % of merchandise exports) in 1964 in Mexico to that in Netherlands?
Make the answer very short. 5.51. What is the ratio of the Exports(as % of merchandise exports) of 1965 in Mexico to that in Netherlands?
Offer a very short reply. 4.8. What is the ratio of the Exports(as % of merchandise exports) in 1962 in Mexico to that in Panama?
Offer a very short reply. 31.37. What is the ratio of the Exports(as % of merchandise exports) of 1963 in Mexico to that in Panama?
Keep it short and to the point. 68.27. What is the ratio of the Exports(as % of merchandise exports) in 1964 in Mexico to that in Panama?
Provide a succinct answer. 42.84. What is the ratio of the Exports(as % of merchandise exports) in 1965 in Mexico to that in Panama?
Offer a very short reply. 21.38. What is the ratio of the Exports(as % of merchandise exports) in 1962 in Netherlands to that in Panama?
Keep it short and to the point. 6.57. What is the ratio of the Exports(as % of merchandise exports) of 1963 in Netherlands to that in Panama?
Provide a short and direct response. 5.6. What is the ratio of the Exports(as % of merchandise exports) of 1964 in Netherlands to that in Panama?
Ensure brevity in your answer.  7.78. What is the ratio of the Exports(as % of merchandise exports) in 1965 in Netherlands to that in Panama?
Make the answer very short. 4.45. What is the difference between the highest and the second highest Exports(as % of merchandise exports) of 1962?
Keep it short and to the point. 16.99. What is the difference between the highest and the second highest Exports(as % of merchandise exports) of 1963?
Keep it short and to the point. 25.12. What is the difference between the highest and the second highest Exports(as % of merchandise exports) of 1964?
Your answer should be very brief. 15.41. What is the difference between the highest and the second highest Exports(as % of merchandise exports) in 1965?
Your response must be concise. 13.74. What is the difference between the highest and the lowest Exports(as % of merchandise exports) of 1962?
Offer a terse response. 20.81. What is the difference between the highest and the lowest Exports(as % of merchandise exports) in 1963?
Provide a succinct answer. 28.68. What is the difference between the highest and the lowest Exports(as % of merchandise exports) of 1964?
Provide a short and direct response. 18.5. What is the difference between the highest and the lowest Exports(as % of merchandise exports) of 1965?
Give a very brief answer. 16.93. 